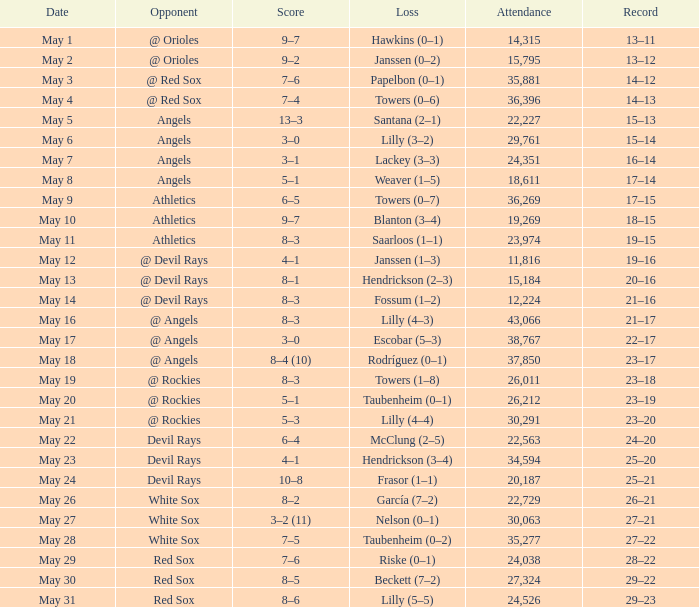For the team with a 16–14 win-loss record, how many people attended in total? 1.0. 